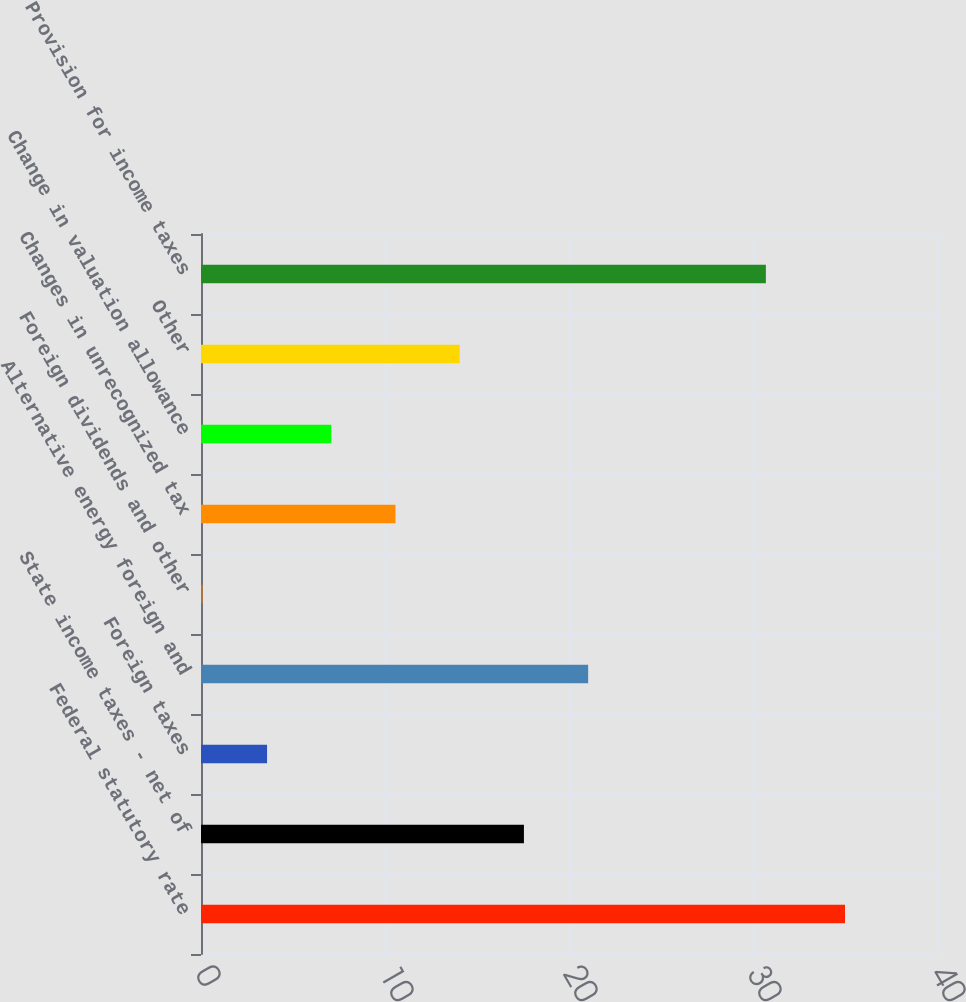Convert chart to OTSL. <chart><loc_0><loc_0><loc_500><loc_500><bar_chart><fcel>Federal statutory rate<fcel>State income taxes - net of<fcel>Foreign taxes<fcel>Alternative energy foreign and<fcel>Foreign dividends and other<fcel>Changes in unrecognized tax<fcel>Change in valuation allowance<fcel>Other<fcel>Provision for income taxes<nl><fcel>35<fcel>17.55<fcel>3.59<fcel>21.04<fcel>0.1<fcel>10.57<fcel>7.08<fcel>14.06<fcel>30.7<nl></chart> 